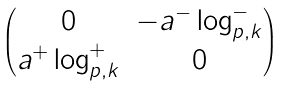<formula> <loc_0><loc_0><loc_500><loc_500>\begin{pmatrix} 0 & - a ^ { - } \log _ { p , k } ^ { - } \\ a ^ { + } \log _ { p , k } ^ { + } & 0 \end{pmatrix}</formula> 